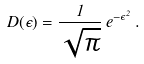Convert formula to latex. <formula><loc_0><loc_0><loc_500><loc_500>D ( \epsilon ) = \frac { 1 } { \sqrt { \pi } } \, e ^ { - \epsilon ^ { 2 } } \, .</formula> 